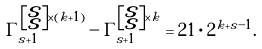<formula> <loc_0><loc_0><loc_500><loc_500>\Gamma _ { s + 1 } ^ { \left [ \substack { s \\ s } \right ] \times ( k + 1 ) } - \Gamma _ { s + 1 } ^ { \left [ \substack { s \\ s } \right ] \times k } = 2 1 \cdot 2 ^ { k + s - 1 } .</formula> 